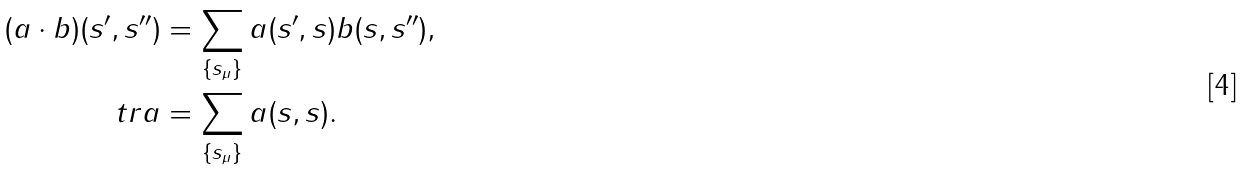<formula> <loc_0><loc_0><loc_500><loc_500>( a \cdot b ) ( s ^ { \prime } , s ^ { \prime \prime } ) & = \sum _ { \{ s _ { \mu } \} } a ( s ^ { \prime } , s ) b ( s , s ^ { \prime \prime } ) , \\ \ t r a & = \sum _ { \{ s _ { \mu } \} } a ( s , s ) .</formula> 